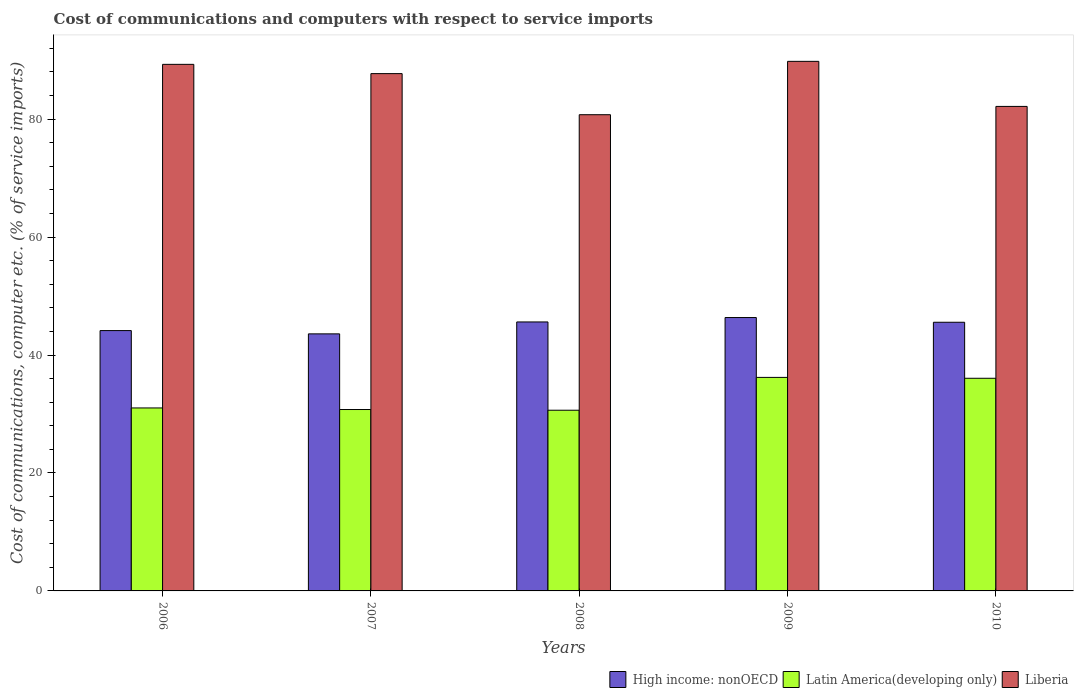Are the number of bars per tick equal to the number of legend labels?
Provide a short and direct response. Yes. How many bars are there on the 2nd tick from the left?
Ensure brevity in your answer.  3. How many bars are there on the 1st tick from the right?
Keep it short and to the point. 3. What is the cost of communications and computers in Liberia in 2008?
Ensure brevity in your answer.  80.74. Across all years, what is the maximum cost of communications and computers in Liberia?
Give a very brief answer. 89.79. Across all years, what is the minimum cost of communications and computers in Liberia?
Your answer should be very brief. 80.74. What is the total cost of communications and computers in High income: nonOECD in the graph?
Your answer should be compact. 225.24. What is the difference between the cost of communications and computers in Latin America(developing only) in 2008 and that in 2009?
Your response must be concise. -5.57. What is the difference between the cost of communications and computers in Latin America(developing only) in 2008 and the cost of communications and computers in Liberia in 2006?
Your response must be concise. -58.65. What is the average cost of communications and computers in High income: nonOECD per year?
Provide a succinct answer. 45.05. In the year 2008, what is the difference between the cost of communications and computers in Liberia and cost of communications and computers in Latin America(developing only)?
Offer a terse response. 50.11. In how many years, is the cost of communications and computers in Latin America(developing only) greater than 16 %?
Your answer should be very brief. 5. What is the ratio of the cost of communications and computers in Latin America(developing only) in 2007 to that in 2008?
Your response must be concise. 1. Is the cost of communications and computers in Latin America(developing only) in 2006 less than that in 2007?
Your answer should be compact. No. Is the difference between the cost of communications and computers in Liberia in 2006 and 2008 greater than the difference between the cost of communications and computers in Latin America(developing only) in 2006 and 2008?
Keep it short and to the point. Yes. What is the difference between the highest and the second highest cost of communications and computers in Latin America(developing only)?
Keep it short and to the point. 0.15. What is the difference between the highest and the lowest cost of communications and computers in Latin America(developing only)?
Provide a succinct answer. 5.57. In how many years, is the cost of communications and computers in High income: nonOECD greater than the average cost of communications and computers in High income: nonOECD taken over all years?
Your answer should be very brief. 3. What does the 2nd bar from the left in 2006 represents?
Give a very brief answer. Latin America(developing only). What does the 1st bar from the right in 2006 represents?
Make the answer very short. Liberia. Is it the case that in every year, the sum of the cost of communications and computers in High income: nonOECD and cost of communications and computers in Liberia is greater than the cost of communications and computers in Latin America(developing only)?
Your answer should be compact. Yes. How many bars are there?
Your response must be concise. 15. How many years are there in the graph?
Provide a short and direct response. 5. What is the difference between two consecutive major ticks on the Y-axis?
Provide a short and direct response. 20. Are the values on the major ticks of Y-axis written in scientific E-notation?
Your response must be concise. No. How are the legend labels stacked?
Your answer should be compact. Horizontal. What is the title of the graph?
Offer a terse response. Cost of communications and computers with respect to service imports. Does "High income" appear as one of the legend labels in the graph?
Make the answer very short. No. What is the label or title of the X-axis?
Provide a short and direct response. Years. What is the label or title of the Y-axis?
Offer a terse response. Cost of communications, computer etc. (% of service imports). What is the Cost of communications, computer etc. (% of service imports) in High income: nonOECD in 2006?
Make the answer very short. 44.14. What is the Cost of communications, computer etc. (% of service imports) in Latin America(developing only) in 2006?
Provide a short and direct response. 31.02. What is the Cost of communications, computer etc. (% of service imports) in Liberia in 2006?
Offer a terse response. 89.28. What is the Cost of communications, computer etc. (% of service imports) in High income: nonOECD in 2007?
Your answer should be compact. 43.59. What is the Cost of communications, computer etc. (% of service imports) in Latin America(developing only) in 2007?
Your answer should be very brief. 30.76. What is the Cost of communications, computer etc. (% of service imports) of Liberia in 2007?
Your answer should be compact. 87.71. What is the Cost of communications, computer etc. (% of service imports) of High income: nonOECD in 2008?
Offer a very short reply. 45.61. What is the Cost of communications, computer etc. (% of service imports) in Latin America(developing only) in 2008?
Make the answer very short. 30.64. What is the Cost of communications, computer etc. (% of service imports) in Liberia in 2008?
Give a very brief answer. 80.74. What is the Cost of communications, computer etc. (% of service imports) in High income: nonOECD in 2009?
Your answer should be compact. 46.35. What is the Cost of communications, computer etc. (% of service imports) of Latin America(developing only) in 2009?
Provide a short and direct response. 36.2. What is the Cost of communications, computer etc. (% of service imports) in Liberia in 2009?
Offer a very short reply. 89.79. What is the Cost of communications, computer etc. (% of service imports) of High income: nonOECD in 2010?
Give a very brief answer. 45.55. What is the Cost of communications, computer etc. (% of service imports) of Latin America(developing only) in 2010?
Give a very brief answer. 36.06. What is the Cost of communications, computer etc. (% of service imports) of Liberia in 2010?
Make the answer very short. 82.15. Across all years, what is the maximum Cost of communications, computer etc. (% of service imports) in High income: nonOECD?
Your response must be concise. 46.35. Across all years, what is the maximum Cost of communications, computer etc. (% of service imports) of Latin America(developing only)?
Keep it short and to the point. 36.2. Across all years, what is the maximum Cost of communications, computer etc. (% of service imports) of Liberia?
Give a very brief answer. 89.79. Across all years, what is the minimum Cost of communications, computer etc. (% of service imports) in High income: nonOECD?
Your answer should be compact. 43.59. Across all years, what is the minimum Cost of communications, computer etc. (% of service imports) in Latin America(developing only)?
Your answer should be very brief. 30.64. Across all years, what is the minimum Cost of communications, computer etc. (% of service imports) of Liberia?
Ensure brevity in your answer.  80.74. What is the total Cost of communications, computer etc. (% of service imports) in High income: nonOECD in the graph?
Ensure brevity in your answer.  225.24. What is the total Cost of communications, computer etc. (% of service imports) of Latin America(developing only) in the graph?
Your answer should be compact. 164.68. What is the total Cost of communications, computer etc. (% of service imports) in Liberia in the graph?
Your answer should be compact. 429.68. What is the difference between the Cost of communications, computer etc. (% of service imports) of High income: nonOECD in 2006 and that in 2007?
Provide a succinct answer. 0.55. What is the difference between the Cost of communications, computer etc. (% of service imports) in Latin America(developing only) in 2006 and that in 2007?
Offer a terse response. 0.27. What is the difference between the Cost of communications, computer etc. (% of service imports) in Liberia in 2006 and that in 2007?
Make the answer very short. 1.57. What is the difference between the Cost of communications, computer etc. (% of service imports) in High income: nonOECD in 2006 and that in 2008?
Your response must be concise. -1.47. What is the difference between the Cost of communications, computer etc. (% of service imports) of Latin America(developing only) in 2006 and that in 2008?
Your response must be concise. 0.39. What is the difference between the Cost of communications, computer etc. (% of service imports) in Liberia in 2006 and that in 2008?
Make the answer very short. 8.54. What is the difference between the Cost of communications, computer etc. (% of service imports) of High income: nonOECD in 2006 and that in 2009?
Keep it short and to the point. -2.21. What is the difference between the Cost of communications, computer etc. (% of service imports) in Latin America(developing only) in 2006 and that in 2009?
Make the answer very short. -5.18. What is the difference between the Cost of communications, computer etc. (% of service imports) in Liberia in 2006 and that in 2009?
Your answer should be compact. -0.51. What is the difference between the Cost of communications, computer etc. (% of service imports) in High income: nonOECD in 2006 and that in 2010?
Keep it short and to the point. -1.41. What is the difference between the Cost of communications, computer etc. (% of service imports) in Latin America(developing only) in 2006 and that in 2010?
Your answer should be very brief. -5.03. What is the difference between the Cost of communications, computer etc. (% of service imports) in Liberia in 2006 and that in 2010?
Keep it short and to the point. 7.13. What is the difference between the Cost of communications, computer etc. (% of service imports) in High income: nonOECD in 2007 and that in 2008?
Provide a short and direct response. -2.02. What is the difference between the Cost of communications, computer etc. (% of service imports) in Latin America(developing only) in 2007 and that in 2008?
Ensure brevity in your answer.  0.12. What is the difference between the Cost of communications, computer etc. (% of service imports) of Liberia in 2007 and that in 2008?
Your answer should be compact. 6.97. What is the difference between the Cost of communications, computer etc. (% of service imports) in High income: nonOECD in 2007 and that in 2009?
Offer a terse response. -2.77. What is the difference between the Cost of communications, computer etc. (% of service imports) in Latin America(developing only) in 2007 and that in 2009?
Your answer should be very brief. -5.45. What is the difference between the Cost of communications, computer etc. (% of service imports) of Liberia in 2007 and that in 2009?
Offer a very short reply. -2.08. What is the difference between the Cost of communications, computer etc. (% of service imports) in High income: nonOECD in 2007 and that in 2010?
Provide a succinct answer. -1.97. What is the difference between the Cost of communications, computer etc. (% of service imports) in Latin America(developing only) in 2007 and that in 2010?
Offer a terse response. -5.3. What is the difference between the Cost of communications, computer etc. (% of service imports) in Liberia in 2007 and that in 2010?
Your answer should be very brief. 5.56. What is the difference between the Cost of communications, computer etc. (% of service imports) in High income: nonOECD in 2008 and that in 2009?
Your answer should be very brief. -0.75. What is the difference between the Cost of communications, computer etc. (% of service imports) of Latin America(developing only) in 2008 and that in 2009?
Offer a terse response. -5.57. What is the difference between the Cost of communications, computer etc. (% of service imports) in Liberia in 2008 and that in 2009?
Your answer should be compact. -9.05. What is the difference between the Cost of communications, computer etc. (% of service imports) of High income: nonOECD in 2008 and that in 2010?
Ensure brevity in your answer.  0.05. What is the difference between the Cost of communications, computer etc. (% of service imports) in Latin America(developing only) in 2008 and that in 2010?
Provide a succinct answer. -5.42. What is the difference between the Cost of communications, computer etc. (% of service imports) of Liberia in 2008 and that in 2010?
Offer a very short reply. -1.41. What is the difference between the Cost of communications, computer etc. (% of service imports) of High income: nonOECD in 2009 and that in 2010?
Make the answer very short. 0.8. What is the difference between the Cost of communications, computer etc. (% of service imports) of Latin America(developing only) in 2009 and that in 2010?
Keep it short and to the point. 0.15. What is the difference between the Cost of communications, computer etc. (% of service imports) of Liberia in 2009 and that in 2010?
Your response must be concise. 7.64. What is the difference between the Cost of communications, computer etc. (% of service imports) in High income: nonOECD in 2006 and the Cost of communications, computer etc. (% of service imports) in Latin America(developing only) in 2007?
Offer a terse response. 13.38. What is the difference between the Cost of communications, computer etc. (% of service imports) in High income: nonOECD in 2006 and the Cost of communications, computer etc. (% of service imports) in Liberia in 2007?
Offer a very short reply. -43.57. What is the difference between the Cost of communications, computer etc. (% of service imports) of Latin America(developing only) in 2006 and the Cost of communications, computer etc. (% of service imports) of Liberia in 2007?
Offer a terse response. -56.69. What is the difference between the Cost of communications, computer etc. (% of service imports) in High income: nonOECD in 2006 and the Cost of communications, computer etc. (% of service imports) in Latin America(developing only) in 2008?
Offer a terse response. 13.5. What is the difference between the Cost of communications, computer etc. (% of service imports) of High income: nonOECD in 2006 and the Cost of communications, computer etc. (% of service imports) of Liberia in 2008?
Your response must be concise. -36.6. What is the difference between the Cost of communications, computer etc. (% of service imports) in Latin America(developing only) in 2006 and the Cost of communications, computer etc. (% of service imports) in Liberia in 2008?
Offer a very short reply. -49.72. What is the difference between the Cost of communications, computer etc. (% of service imports) in High income: nonOECD in 2006 and the Cost of communications, computer etc. (% of service imports) in Latin America(developing only) in 2009?
Keep it short and to the point. 7.94. What is the difference between the Cost of communications, computer etc. (% of service imports) of High income: nonOECD in 2006 and the Cost of communications, computer etc. (% of service imports) of Liberia in 2009?
Offer a very short reply. -45.65. What is the difference between the Cost of communications, computer etc. (% of service imports) in Latin America(developing only) in 2006 and the Cost of communications, computer etc. (% of service imports) in Liberia in 2009?
Offer a terse response. -58.77. What is the difference between the Cost of communications, computer etc. (% of service imports) in High income: nonOECD in 2006 and the Cost of communications, computer etc. (% of service imports) in Latin America(developing only) in 2010?
Give a very brief answer. 8.08. What is the difference between the Cost of communications, computer etc. (% of service imports) in High income: nonOECD in 2006 and the Cost of communications, computer etc. (% of service imports) in Liberia in 2010?
Provide a succinct answer. -38.01. What is the difference between the Cost of communications, computer etc. (% of service imports) in Latin America(developing only) in 2006 and the Cost of communications, computer etc. (% of service imports) in Liberia in 2010?
Your answer should be very brief. -51.13. What is the difference between the Cost of communications, computer etc. (% of service imports) of High income: nonOECD in 2007 and the Cost of communications, computer etc. (% of service imports) of Latin America(developing only) in 2008?
Your answer should be compact. 12.95. What is the difference between the Cost of communications, computer etc. (% of service imports) in High income: nonOECD in 2007 and the Cost of communications, computer etc. (% of service imports) in Liberia in 2008?
Your response must be concise. -37.16. What is the difference between the Cost of communications, computer etc. (% of service imports) in Latin America(developing only) in 2007 and the Cost of communications, computer etc. (% of service imports) in Liberia in 2008?
Keep it short and to the point. -49.99. What is the difference between the Cost of communications, computer etc. (% of service imports) in High income: nonOECD in 2007 and the Cost of communications, computer etc. (% of service imports) in Latin America(developing only) in 2009?
Ensure brevity in your answer.  7.38. What is the difference between the Cost of communications, computer etc. (% of service imports) in High income: nonOECD in 2007 and the Cost of communications, computer etc. (% of service imports) in Liberia in 2009?
Make the answer very short. -46.21. What is the difference between the Cost of communications, computer etc. (% of service imports) of Latin America(developing only) in 2007 and the Cost of communications, computer etc. (% of service imports) of Liberia in 2009?
Provide a succinct answer. -59.03. What is the difference between the Cost of communications, computer etc. (% of service imports) of High income: nonOECD in 2007 and the Cost of communications, computer etc. (% of service imports) of Latin America(developing only) in 2010?
Provide a short and direct response. 7.53. What is the difference between the Cost of communications, computer etc. (% of service imports) in High income: nonOECD in 2007 and the Cost of communications, computer etc. (% of service imports) in Liberia in 2010?
Provide a succinct answer. -38.56. What is the difference between the Cost of communications, computer etc. (% of service imports) in Latin America(developing only) in 2007 and the Cost of communications, computer etc. (% of service imports) in Liberia in 2010?
Offer a terse response. -51.39. What is the difference between the Cost of communications, computer etc. (% of service imports) in High income: nonOECD in 2008 and the Cost of communications, computer etc. (% of service imports) in Latin America(developing only) in 2009?
Your answer should be compact. 9.4. What is the difference between the Cost of communications, computer etc. (% of service imports) in High income: nonOECD in 2008 and the Cost of communications, computer etc. (% of service imports) in Liberia in 2009?
Keep it short and to the point. -44.19. What is the difference between the Cost of communications, computer etc. (% of service imports) in Latin America(developing only) in 2008 and the Cost of communications, computer etc. (% of service imports) in Liberia in 2009?
Provide a succinct answer. -59.15. What is the difference between the Cost of communications, computer etc. (% of service imports) of High income: nonOECD in 2008 and the Cost of communications, computer etc. (% of service imports) of Latin America(developing only) in 2010?
Your response must be concise. 9.55. What is the difference between the Cost of communications, computer etc. (% of service imports) in High income: nonOECD in 2008 and the Cost of communications, computer etc. (% of service imports) in Liberia in 2010?
Make the answer very short. -36.55. What is the difference between the Cost of communications, computer etc. (% of service imports) in Latin America(developing only) in 2008 and the Cost of communications, computer etc. (% of service imports) in Liberia in 2010?
Keep it short and to the point. -51.51. What is the difference between the Cost of communications, computer etc. (% of service imports) of High income: nonOECD in 2009 and the Cost of communications, computer etc. (% of service imports) of Latin America(developing only) in 2010?
Make the answer very short. 10.3. What is the difference between the Cost of communications, computer etc. (% of service imports) in High income: nonOECD in 2009 and the Cost of communications, computer etc. (% of service imports) in Liberia in 2010?
Your answer should be very brief. -35.8. What is the difference between the Cost of communications, computer etc. (% of service imports) in Latin America(developing only) in 2009 and the Cost of communications, computer etc. (% of service imports) in Liberia in 2010?
Provide a succinct answer. -45.95. What is the average Cost of communications, computer etc. (% of service imports) of High income: nonOECD per year?
Give a very brief answer. 45.05. What is the average Cost of communications, computer etc. (% of service imports) of Latin America(developing only) per year?
Provide a short and direct response. 32.94. What is the average Cost of communications, computer etc. (% of service imports) in Liberia per year?
Your response must be concise. 85.94. In the year 2006, what is the difference between the Cost of communications, computer etc. (% of service imports) of High income: nonOECD and Cost of communications, computer etc. (% of service imports) of Latin America(developing only)?
Provide a succinct answer. 13.12. In the year 2006, what is the difference between the Cost of communications, computer etc. (% of service imports) of High income: nonOECD and Cost of communications, computer etc. (% of service imports) of Liberia?
Give a very brief answer. -45.14. In the year 2006, what is the difference between the Cost of communications, computer etc. (% of service imports) of Latin America(developing only) and Cost of communications, computer etc. (% of service imports) of Liberia?
Give a very brief answer. -58.26. In the year 2007, what is the difference between the Cost of communications, computer etc. (% of service imports) of High income: nonOECD and Cost of communications, computer etc. (% of service imports) of Latin America(developing only)?
Provide a short and direct response. 12.83. In the year 2007, what is the difference between the Cost of communications, computer etc. (% of service imports) in High income: nonOECD and Cost of communications, computer etc. (% of service imports) in Liberia?
Ensure brevity in your answer.  -44.13. In the year 2007, what is the difference between the Cost of communications, computer etc. (% of service imports) in Latin America(developing only) and Cost of communications, computer etc. (% of service imports) in Liberia?
Make the answer very short. -56.96. In the year 2008, what is the difference between the Cost of communications, computer etc. (% of service imports) in High income: nonOECD and Cost of communications, computer etc. (% of service imports) in Latin America(developing only)?
Your answer should be compact. 14.97. In the year 2008, what is the difference between the Cost of communications, computer etc. (% of service imports) of High income: nonOECD and Cost of communications, computer etc. (% of service imports) of Liberia?
Your answer should be compact. -35.14. In the year 2008, what is the difference between the Cost of communications, computer etc. (% of service imports) in Latin America(developing only) and Cost of communications, computer etc. (% of service imports) in Liberia?
Give a very brief answer. -50.11. In the year 2009, what is the difference between the Cost of communications, computer etc. (% of service imports) of High income: nonOECD and Cost of communications, computer etc. (% of service imports) of Latin America(developing only)?
Your response must be concise. 10.15. In the year 2009, what is the difference between the Cost of communications, computer etc. (% of service imports) of High income: nonOECD and Cost of communications, computer etc. (% of service imports) of Liberia?
Give a very brief answer. -43.44. In the year 2009, what is the difference between the Cost of communications, computer etc. (% of service imports) of Latin America(developing only) and Cost of communications, computer etc. (% of service imports) of Liberia?
Your answer should be compact. -53.59. In the year 2010, what is the difference between the Cost of communications, computer etc. (% of service imports) of High income: nonOECD and Cost of communications, computer etc. (% of service imports) of Latin America(developing only)?
Give a very brief answer. 9.5. In the year 2010, what is the difference between the Cost of communications, computer etc. (% of service imports) of High income: nonOECD and Cost of communications, computer etc. (% of service imports) of Liberia?
Offer a very short reply. -36.6. In the year 2010, what is the difference between the Cost of communications, computer etc. (% of service imports) in Latin America(developing only) and Cost of communications, computer etc. (% of service imports) in Liberia?
Your answer should be very brief. -46.09. What is the ratio of the Cost of communications, computer etc. (% of service imports) of High income: nonOECD in 2006 to that in 2007?
Offer a terse response. 1.01. What is the ratio of the Cost of communications, computer etc. (% of service imports) of Latin America(developing only) in 2006 to that in 2007?
Your answer should be very brief. 1.01. What is the ratio of the Cost of communications, computer etc. (% of service imports) in Liberia in 2006 to that in 2007?
Your answer should be very brief. 1.02. What is the ratio of the Cost of communications, computer etc. (% of service imports) of High income: nonOECD in 2006 to that in 2008?
Provide a succinct answer. 0.97. What is the ratio of the Cost of communications, computer etc. (% of service imports) in Latin America(developing only) in 2006 to that in 2008?
Your answer should be very brief. 1.01. What is the ratio of the Cost of communications, computer etc. (% of service imports) of Liberia in 2006 to that in 2008?
Offer a very short reply. 1.11. What is the ratio of the Cost of communications, computer etc. (% of service imports) of High income: nonOECD in 2006 to that in 2009?
Offer a terse response. 0.95. What is the ratio of the Cost of communications, computer etc. (% of service imports) of Latin America(developing only) in 2006 to that in 2009?
Provide a succinct answer. 0.86. What is the ratio of the Cost of communications, computer etc. (% of service imports) of Liberia in 2006 to that in 2009?
Give a very brief answer. 0.99. What is the ratio of the Cost of communications, computer etc. (% of service imports) in High income: nonOECD in 2006 to that in 2010?
Provide a succinct answer. 0.97. What is the ratio of the Cost of communications, computer etc. (% of service imports) in Latin America(developing only) in 2006 to that in 2010?
Your answer should be very brief. 0.86. What is the ratio of the Cost of communications, computer etc. (% of service imports) in Liberia in 2006 to that in 2010?
Your answer should be very brief. 1.09. What is the ratio of the Cost of communications, computer etc. (% of service imports) of High income: nonOECD in 2007 to that in 2008?
Your answer should be compact. 0.96. What is the ratio of the Cost of communications, computer etc. (% of service imports) in Liberia in 2007 to that in 2008?
Provide a short and direct response. 1.09. What is the ratio of the Cost of communications, computer etc. (% of service imports) in High income: nonOECD in 2007 to that in 2009?
Provide a succinct answer. 0.94. What is the ratio of the Cost of communications, computer etc. (% of service imports) of Latin America(developing only) in 2007 to that in 2009?
Keep it short and to the point. 0.85. What is the ratio of the Cost of communications, computer etc. (% of service imports) in Liberia in 2007 to that in 2009?
Provide a short and direct response. 0.98. What is the ratio of the Cost of communications, computer etc. (% of service imports) of High income: nonOECD in 2007 to that in 2010?
Keep it short and to the point. 0.96. What is the ratio of the Cost of communications, computer etc. (% of service imports) of Latin America(developing only) in 2007 to that in 2010?
Your response must be concise. 0.85. What is the ratio of the Cost of communications, computer etc. (% of service imports) in Liberia in 2007 to that in 2010?
Provide a succinct answer. 1.07. What is the ratio of the Cost of communications, computer etc. (% of service imports) of High income: nonOECD in 2008 to that in 2009?
Your response must be concise. 0.98. What is the ratio of the Cost of communications, computer etc. (% of service imports) of Latin America(developing only) in 2008 to that in 2009?
Ensure brevity in your answer.  0.85. What is the ratio of the Cost of communications, computer etc. (% of service imports) in Liberia in 2008 to that in 2009?
Provide a succinct answer. 0.9. What is the ratio of the Cost of communications, computer etc. (% of service imports) in High income: nonOECD in 2008 to that in 2010?
Make the answer very short. 1. What is the ratio of the Cost of communications, computer etc. (% of service imports) in Latin America(developing only) in 2008 to that in 2010?
Keep it short and to the point. 0.85. What is the ratio of the Cost of communications, computer etc. (% of service imports) of Liberia in 2008 to that in 2010?
Your answer should be very brief. 0.98. What is the ratio of the Cost of communications, computer etc. (% of service imports) in High income: nonOECD in 2009 to that in 2010?
Offer a very short reply. 1.02. What is the ratio of the Cost of communications, computer etc. (% of service imports) of Latin America(developing only) in 2009 to that in 2010?
Ensure brevity in your answer.  1. What is the ratio of the Cost of communications, computer etc. (% of service imports) in Liberia in 2009 to that in 2010?
Offer a terse response. 1.09. What is the difference between the highest and the second highest Cost of communications, computer etc. (% of service imports) in High income: nonOECD?
Offer a very short reply. 0.75. What is the difference between the highest and the second highest Cost of communications, computer etc. (% of service imports) in Latin America(developing only)?
Your answer should be compact. 0.15. What is the difference between the highest and the second highest Cost of communications, computer etc. (% of service imports) in Liberia?
Your response must be concise. 0.51. What is the difference between the highest and the lowest Cost of communications, computer etc. (% of service imports) of High income: nonOECD?
Offer a terse response. 2.77. What is the difference between the highest and the lowest Cost of communications, computer etc. (% of service imports) in Latin America(developing only)?
Provide a succinct answer. 5.57. What is the difference between the highest and the lowest Cost of communications, computer etc. (% of service imports) in Liberia?
Give a very brief answer. 9.05. 